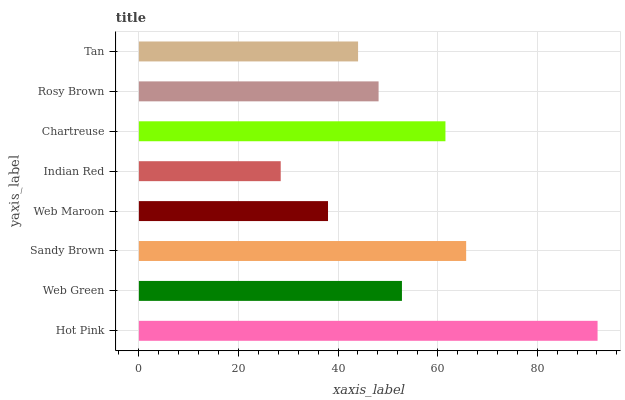Is Indian Red the minimum?
Answer yes or no. Yes. Is Hot Pink the maximum?
Answer yes or no. Yes. Is Web Green the minimum?
Answer yes or no. No. Is Web Green the maximum?
Answer yes or no. No. Is Hot Pink greater than Web Green?
Answer yes or no. Yes. Is Web Green less than Hot Pink?
Answer yes or no. Yes. Is Web Green greater than Hot Pink?
Answer yes or no. No. Is Hot Pink less than Web Green?
Answer yes or no. No. Is Web Green the high median?
Answer yes or no. Yes. Is Rosy Brown the low median?
Answer yes or no. Yes. Is Chartreuse the high median?
Answer yes or no. No. Is Hot Pink the low median?
Answer yes or no. No. 